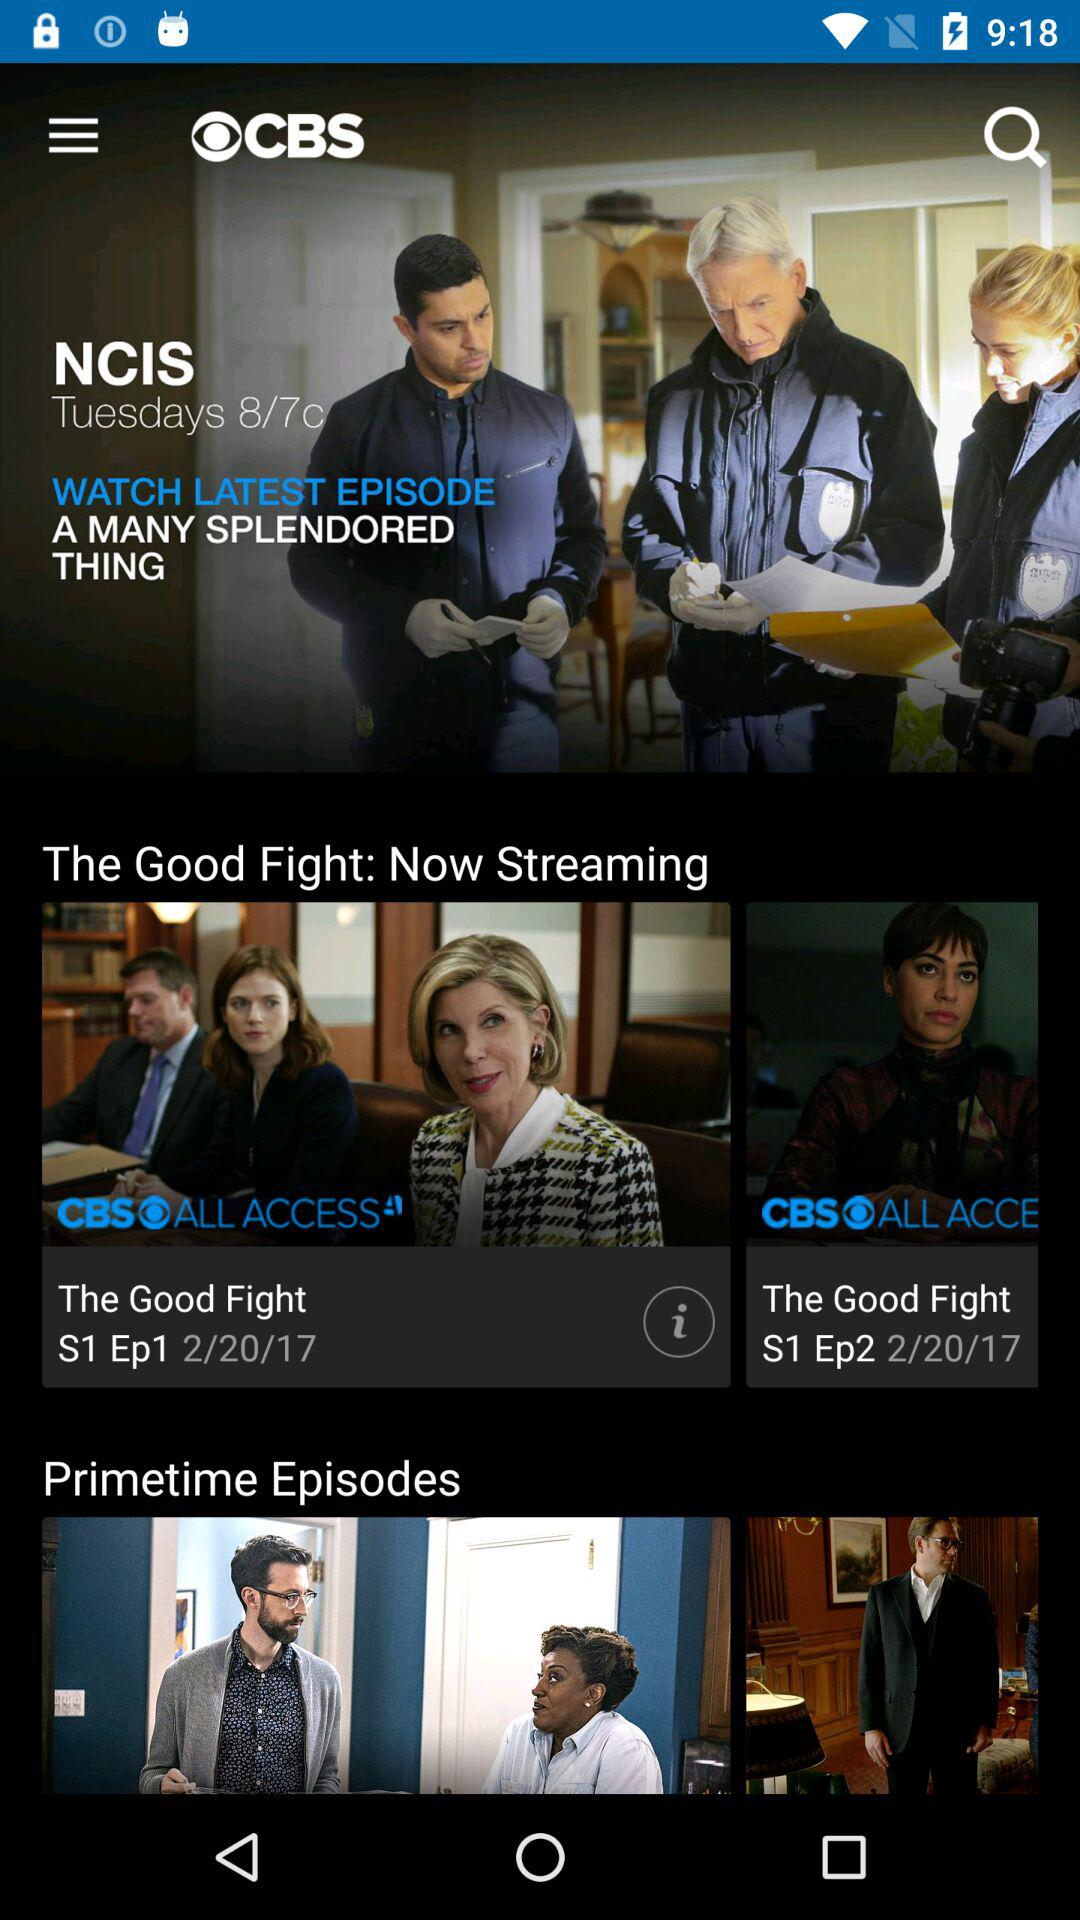What is the selected date? The selected date is Wednesday, February 22, 2017. 